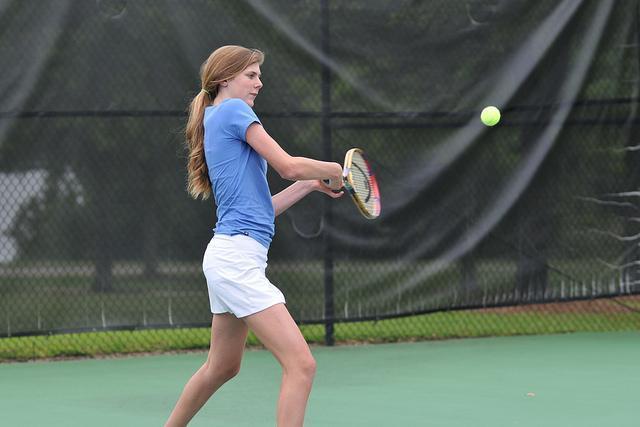How many tennis balls are there?
Give a very brief answer. 1. How many cats are there?
Give a very brief answer. 0. 